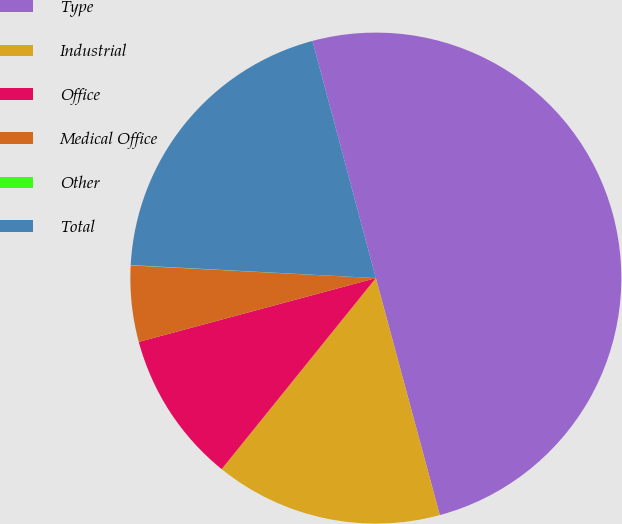<chart> <loc_0><loc_0><loc_500><loc_500><pie_chart><fcel>Type<fcel>Industrial<fcel>Office<fcel>Medical Office<fcel>Other<fcel>Total<nl><fcel>49.96%<fcel>15.0%<fcel>10.01%<fcel>5.01%<fcel>0.02%<fcel>20.0%<nl></chart> 